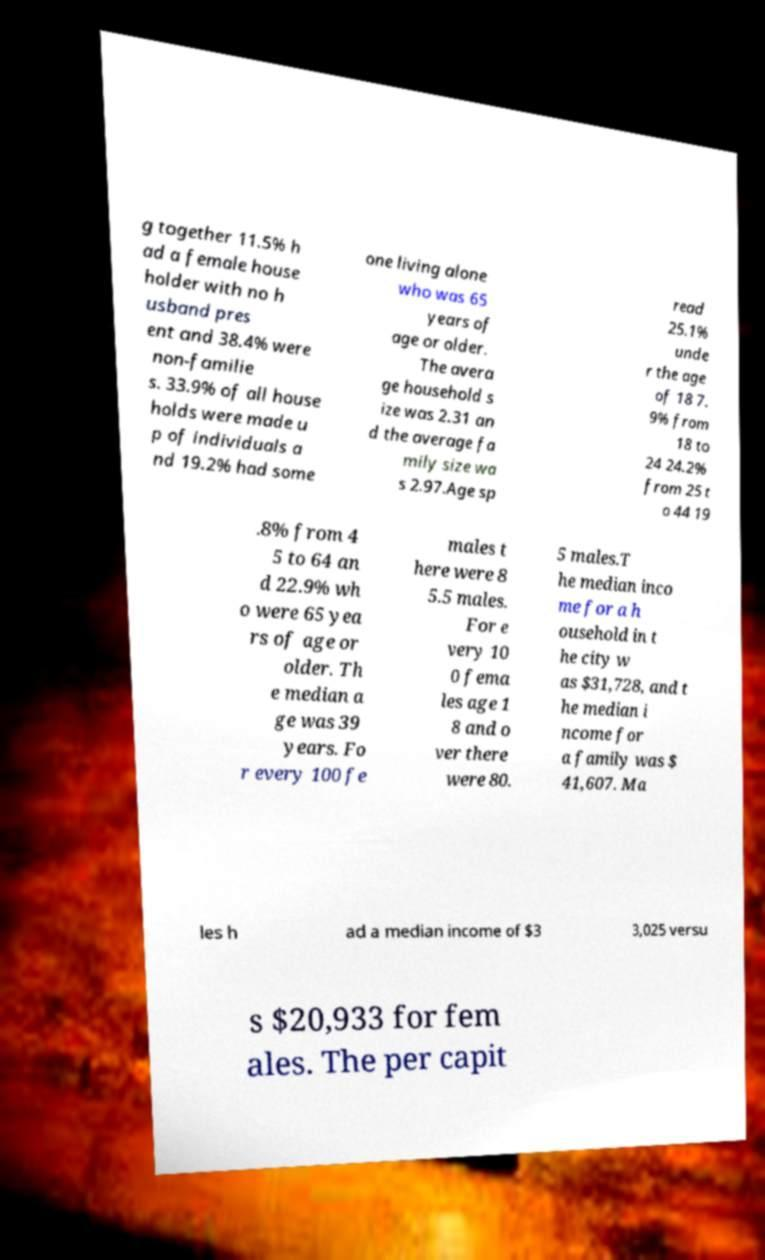Could you assist in decoding the text presented in this image and type it out clearly? g together 11.5% h ad a female house holder with no h usband pres ent and 38.4% were non-familie s. 33.9% of all house holds were made u p of individuals a nd 19.2% had some one living alone who was 65 years of age or older. The avera ge household s ize was 2.31 an d the average fa mily size wa s 2.97.Age sp read 25.1% unde r the age of 18 7. 9% from 18 to 24 24.2% from 25 t o 44 19 .8% from 4 5 to 64 an d 22.9% wh o were 65 yea rs of age or older. Th e median a ge was 39 years. Fo r every 100 fe males t here were 8 5.5 males. For e very 10 0 fema les age 1 8 and o ver there were 80. 5 males.T he median inco me for a h ousehold in t he city w as $31,728, and t he median i ncome for a family was $ 41,607. Ma les h ad a median income of $3 3,025 versu s $20,933 for fem ales. The per capit 